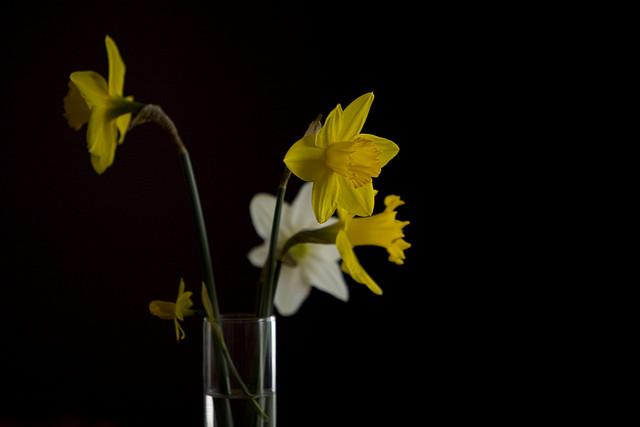What is the yellow flower called?
Quick response, please. Daffodil. What material is the vase made of?
Concise answer only. Glass. Are there more flowers than are seen in the picture?
Be succinct. No. How full of water is the vase?
Concise answer only. Half. How many flowers are in the vase?
Be succinct. 5. 